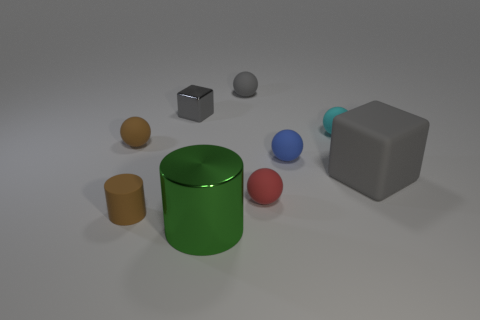Subtract all blue balls. How many balls are left? 4 Subtract all blue balls. How many balls are left? 4 Subtract all yellow balls. Subtract all purple cubes. How many balls are left? 5 Add 1 green metal objects. How many objects exist? 10 Subtract all blocks. How many objects are left? 7 Add 3 small brown cylinders. How many small brown cylinders are left? 4 Add 1 cyan matte cubes. How many cyan matte cubes exist? 1 Subtract 1 brown spheres. How many objects are left? 8 Subtract all green metal things. Subtract all tiny red matte objects. How many objects are left? 7 